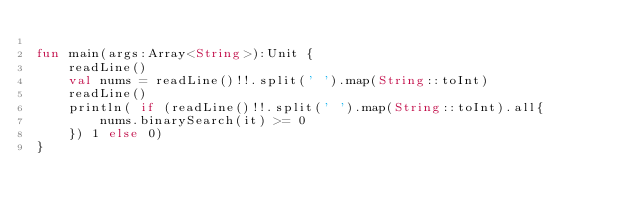<code> <loc_0><loc_0><loc_500><loc_500><_Kotlin_>
fun main(args:Array<String>):Unit {
    readLine()
    val nums = readLine()!!.split(' ').map(String::toInt)
    readLine()
    println( if (readLine()!!.split(' ').map(String::toInt).all{
        nums.binarySearch(it) >= 0
    }) 1 else 0)
}
</code> 